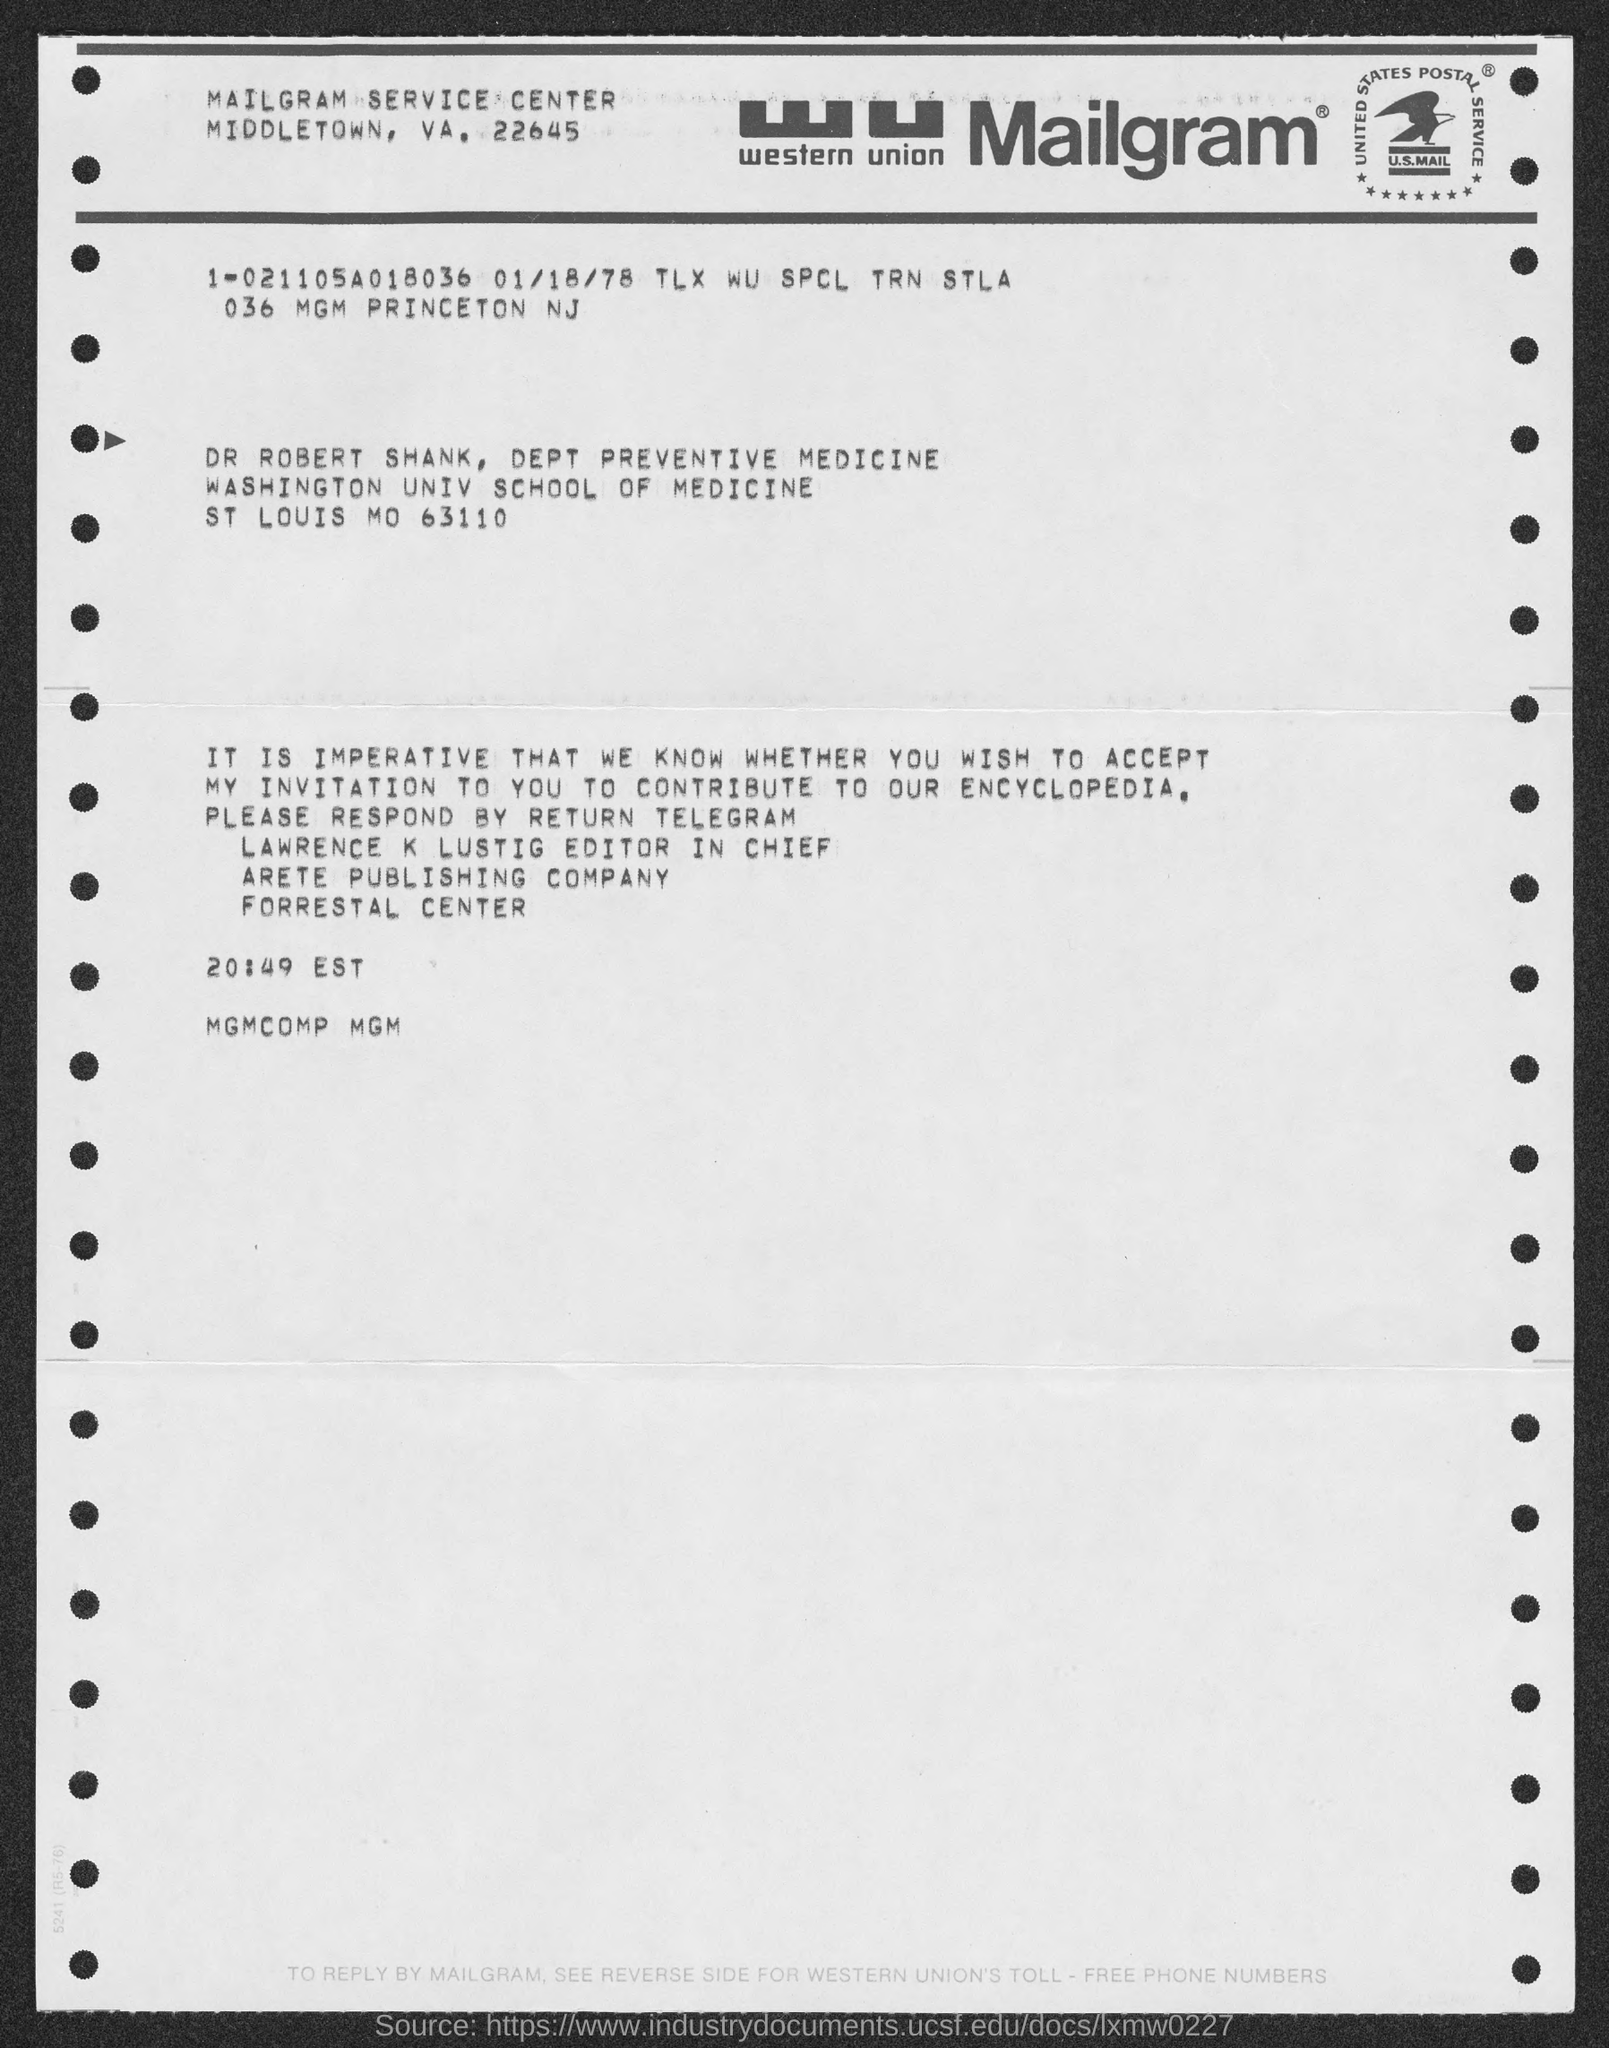To whom is the mailgram addressed?
Offer a terse response. Dr. Robert Shank. Who is the editor in chief?
Offer a terse response. LAWRENCE K LUSTIG. Which publishing company is LAWRENCE part of?
Provide a short and direct response. Arete. 